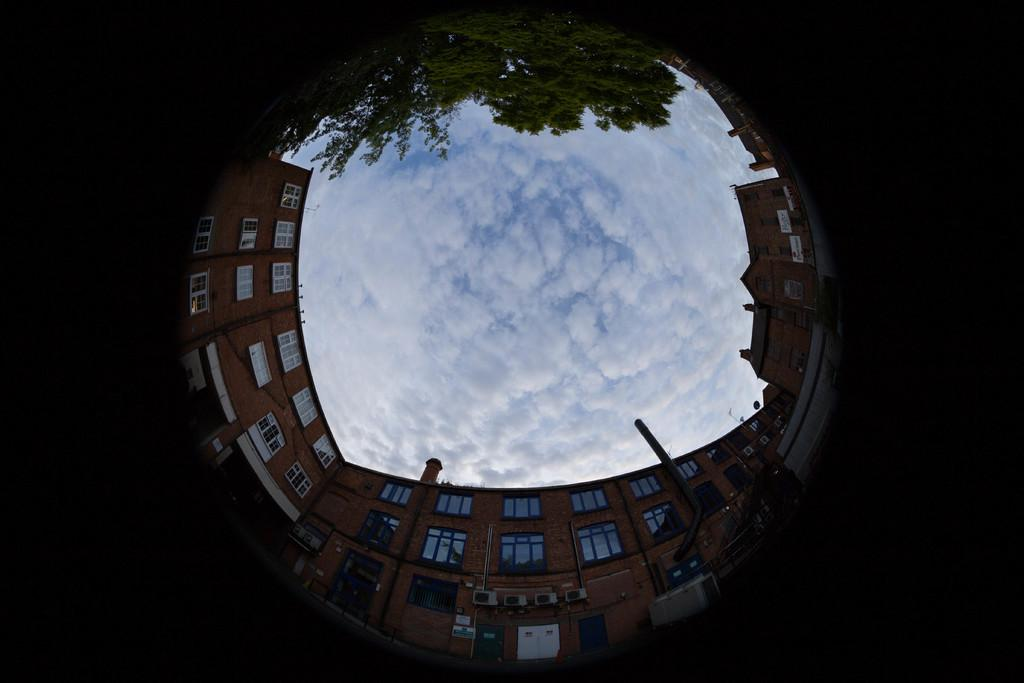What type of structures can be seen in the image? There are buildings in the image. What other natural elements are present in the image? There are trees in the image. What is visible at the top of the image? The sky is visible at the top of the image. What type of weather can be seen in the image? The provided facts do not mention any specific weather conditions, so we cannot determine the weather from the image. Has the area depicted in the image experienced any destruction? There is no indication of destruction in the image, as it primarily features buildings, trees, and the sky. 